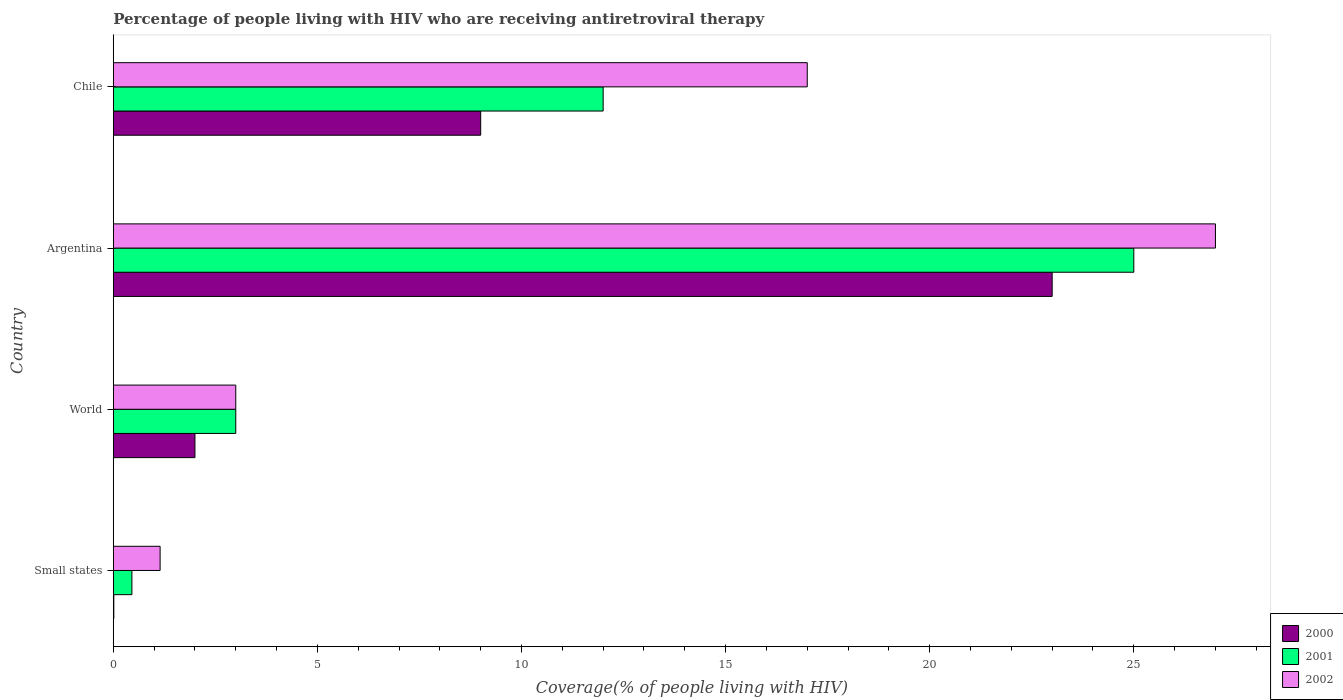How many groups of bars are there?
Offer a very short reply. 4. Are the number of bars per tick equal to the number of legend labels?
Make the answer very short. Yes. Are the number of bars on each tick of the Y-axis equal?
Make the answer very short. Yes. How many bars are there on the 1st tick from the bottom?
Offer a terse response. 3. What is the percentage of the HIV infected people who are receiving antiretroviral therapy in 2000 in Argentina?
Ensure brevity in your answer.  23. Across all countries, what is the minimum percentage of the HIV infected people who are receiving antiretroviral therapy in 2002?
Your answer should be compact. 1.15. In which country was the percentage of the HIV infected people who are receiving antiretroviral therapy in 2000 minimum?
Make the answer very short. Small states. What is the total percentage of the HIV infected people who are receiving antiretroviral therapy in 2001 in the graph?
Offer a terse response. 40.45. What is the difference between the percentage of the HIV infected people who are receiving antiretroviral therapy in 2002 in Small states and that in World?
Offer a very short reply. -1.85. What is the difference between the percentage of the HIV infected people who are receiving antiretroviral therapy in 2000 in Small states and the percentage of the HIV infected people who are receiving antiretroviral therapy in 2001 in Chile?
Your response must be concise. -11.99. What is the average percentage of the HIV infected people who are receiving antiretroviral therapy in 2002 per country?
Make the answer very short. 12.04. What is the difference between the percentage of the HIV infected people who are receiving antiretroviral therapy in 2000 and percentage of the HIV infected people who are receiving antiretroviral therapy in 2002 in Chile?
Give a very brief answer. -8. What is the ratio of the percentage of the HIV infected people who are receiving antiretroviral therapy in 2000 in Small states to that in World?
Make the answer very short. 0.01. Is the difference between the percentage of the HIV infected people who are receiving antiretroviral therapy in 2000 in Argentina and Small states greater than the difference between the percentage of the HIV infected people who are receiving antiretroviral therapy in 2002 in Argentina and Small states?
Your response must be concise. No. What is the difference between the highest and the lowest percentage of the HIV infected people who are receiving antiretroviral therapy in 2001?
Ensure brevity in your answer.  24.55. In how many countries, is the percentage of the HIV infected people who are receiving antiretroviral therapy in 2001 greater than the average percentage of the HIV infected people who are receiving antiretroviral therapy in 2001 taken over all countries?
Your response must be concise. 2. Is the sum of the percentage of the HIV infected people who are receiving antiretroviral therapy in 2001 in Chile and World greater than the maximum percentage of the HIV infected people who are receiving antiretroviral therapy in 2000 across all countries?
Make the answer very short. No. What does the 2nd bar from the top in Argentina represents?
Offer a terse response. 2001. What does the 3rd bar from the bottom in Argentina represents?
Give a very brief answer. 2002. How many bars are there?
Your response must be concise. 12. Are all the bars in the graph horizontal?
Your answer should be compact. Yes. How many countries are there in the graph?
Offer a terse response. 4. What is the difference between two consecutive major ticks on the X-axis?
Make the answer very short. 5. Are the values on the major ticks of X-axis written in scientific E-notation?
Your answer should be compact. No. Does the graph contain grids?
Your answer should be very brief. No. How many legend labels are there?
Make the answer very short. 3. How are the legend labels stacked?
Provide a short and direct response. Vertical. What is the title of the graph?
Make the answer very short. Percentage of people living with HIV who are receiving antiretroviral therapy. What is the label or title of the X-axis?
Your answer should be compact. Coverage(% of people living with HIV). What is the label or title of the Y-axis?
Give a very brief answer. Country. What is the Coverage(% of people living with HIV) of 2000 in Small states?
Make the answer very short. 0.01. What is the Coverage(% of people living with HIV) of 2001 in Small states?
Provide a short and direct response. 0.45. What is the Coverage(% of people living with HIV) of 2002 in Small states?
Your answer should be compact. 1.15. What is the Coverage(% of people living with HIV) in 2000 in World?
Ensure brevity in your answer.  2. What is the Coverage(% of people living with HIV) in 2001 in World?
Give a very brief answer. 3. What is the Coverage(% of people living with HIV) in 2002 in World?
Make the answer very short. 3. What is the Coverage(% of people living with HIV) of 2000 in Argentina?
Make the answer very short. 23. What is the Coverage(% of people living with HIV) in 2001 in Argentina?
Ensure brevity in your answer.  25. What is the Coverage(% of people living with HIV) of 2000 in Chile?
Ensure brevity in your answer.  9. What is the Coverage(% of people living with HIV) of 2001 in Chile?
Your answer should be compact. 12. Across all countries, what is the maximum Coverage(% of people living with HIV) in 2001?
Your answer should be compact. 25. Across all countries, what is the minimum Coverage(% of people living with HIV) in 2000?
Your response must be concise. 0.01. Across all countries, what is the minimum Coverage(% of people living with HIV) in 2001?
Your response must be concise. 0.45. Across all countries, what is the minimum Coverage(% of people living with HIV) in 2002?
Provide a succinct answer. 1.15. What is the total Coverage(% of people living with HIV) in 2000 in the graph?
Provide a short and direct response. 34.01. What is the total Coverage(% of people living with HIV) of 2001 in the graph?
Provide a succinct answer. 40.45. What is the total Coverage(% of people living with HIV) in 2002 in the graph?
Your answer should be compact. 48.15. What is the difference between the Coverage(% of people living with HIV) of 2000 in Small states and that in World?
Keep it short and to the point. -1.99. What is the difference between the Coverage(% of people living with HIV) in 2001 in Small states and that in World?
Provide a short and direct response. -2.54. What is the difference between the Coverage(% of people living with HIV) of 2002 in Small states and that in World?
Ensure brevity in your answer.  -1.85. What is the difference between the Coverage(% of people living with HIV) of 2000 in Small states and that in Argentina?
Offer a very short reply. -22.99. What is the difference between the Coverage(% of people living with HIV) in 2001 in Small states and that in Argentina?
Provide a short and direct response. -24.55. What is the difference between the Coverage(% of people living with HIV) in 2002 in Small states and that in Argentina?
Ensure brevity in your answer.  -25.85. What is the difference between the Coverage(% of people living with HIV) in 2000 in Small states and that in Chile?
Provide a short and direct response. -8.99. What is the difference between the Coverage(% of people living with HIV) of 2001 in Small states and that in Chile?
Offer a terse response. -11.54. What is the difference between the Coverage(% of people living with HIV) in 2002 in Small states and that in Chile?
Ensure brevity in your answer.  -15.85. What is the difference between the Coverage(% of people living with HIV) of 2000 in World and that in Argentina?
Keep it short and to the point. -21. What is the difference between the Coverage(% of people living with HIV) in 2000 in Small states and the Coverage(% of people living with HIV) in 2001 in World?
Provide a short and direct response. -2.99. What is the difference between the Coverage(% of people living with HIV) of 2000 in Small states and the Coverage(% of people living with HIV) of 2002 in World?
Your answer should be compact. -2.99. What is the difference between the Coverage(% of people living with HIV) of 2001 in Small states and the Coverage(% of people living with HIV) of 2002 in World?
Keep it short and to the point. -2.54. What is the difference between the Coverage(% of people living with HIV) of 2000 in Small states and the Coverage(% of people living with HIV) of 2001 in Argentina?
Provide a succinct answer. -24.99. What is the difference between the Coverage(% of people living with HIV) of 2000 in Small states and the Coverage(% of people living with HIV) of 2002 in Argentina?
Give a very brief answer. -26.99. What is the difference between the Coverage(% of people living with HIV) in 2001 in Small states and the Coverage(% of people living with HIV) in 2002 in Argentina?
Ensure brevity in your answer.  -26.55. What is the difference between the Coverage(% of people living with HIV) in 2000 in Small states and the Coverage(% of people living with HIV) in 2001 in Chile?
Offer a very short reply. -11.99. What is the difference between the Coverage(% of people living with HIV) of 2000 in Small states and the Coverage(% of people living with HIV) of 2002 in Chile?
Your answer should be compact. -16.99. What is the difference between the Coverage(% of people living with HIV) of 2001 in Small states and the Coverage(% of people living with HIV) of 2002 in Chile?
Keep it short and to the point. -16.55. What is the difference between the Coverage(% of people living with HIV) in 2000 in World and the Coverage(% of people living with HIV) in 2001 in Chile?
Offer a very short reply. -10. What is the difference between the Coverage(% of people living with HIV) of 2000 in World and the Coverage(% of people living with HIV) of 2002 in Chile?
Make the answer very short. -15. What is the difference between the Coverage(% of people living with HIV) in 2001 in Argentina and the Coverage(% of people living with HIV) in 2002 in Chile?
Offer a terse response. 8. What is the average Coverage(% of people living with HIV) in 2000 per country?
Keep it short and to the point. 8.5. What is the average Coverage(% of people living with HIV) in 2001 per country?
Offer a very short reply. 10.11. What is the average Coverage(% of people living with HIV) in 2002 per country?
Make the answer very short. 12.04. What is the difference between the Coverage(% of people living with HIV) in 2000 and Coverage(% of people living with HIV) in 2001 in Small states?
Your answer should be compact. -0.44. What is the difference between the Coverage(% of people living with HIV) of 2000 and Coverage(% of people living with HIV) of 2002 in Small states?
Offer a terse response. -1.13. What is the difference between the Coverage(% of people living with HIV) in 2001 and Coverage(% of people living with HIV) in 2002 in Small states?
Give a very brief answer. -0.69. What is the difference between the Coverage(% of people living with HIV) of 2000 and Coverage(% of people living with HIV) of 2001 in World?
Your answer should be very brief. -1. What is the difference between the Coverage(% of people living with HIV) of 2000 and Coverage(% of people living with HIV) of 2002 in World?
Your answer should be very brief. -1. What is the difference between the Coverage(% of people living with HIV) of 2000 and Coverage(% of people living with HIV) of 2001 in Argentina?
Your answer should be very brief. -2. What is the difference between the Coverage(% of people living with HIV) of 2000 and Coverage(% of people living with HIV) of 2002 in Argentina?
Ensure brevity in your answer.  -4. What is the difference between the Coverage(% of people living with HIV) in 2000 and Coverage(% of people living with HIV) in 2001 in Chile?
Keep it short and to the point. -3. What is the difference between the Coverage(% of people living with HIV) in 2001 and Coverage(% of people living with HIV) in 2002 in Chile?
Keep it short and to the point. -5. What is the ratio of the Coverage(% of people living with HIV) of 2000 in Small states to that in World?
Ensure brevity in your answer.  0.01. What is the ratio of the Coverage(% of people living with HIV) in 2001 in Small states to that in World?
Offer a very short reply. 0.15. What is the ratio of the Coverage(% of people living with HIV) of 2002 in Small states to that in World?
Provide a succinct answer. 0.38. What is the ratio of the Coverage(% of people living with HIV) of 2001 in Small states to that in Argentina?
Provide a short and direct response. 0.02. What is the ratio of the Coverage(% of people living with HIV) in 2002 in Small states to that in Argentina?
Your response must be concise. 0.04. What is the ratio of the Coverage(% of people living with HIV) in 2000 in Small states to that in Chile?
Your response must be concise. 0. What is the ratio of the Coverage(% of people living with HIV) in 2001 in Small states to that in Chile?
Your response must be concise. 0.04. What is the ratio of the Coverage(% of people living with HIV) in 2002 in Small states to that in Chile?
Your response must be concise. 0.07. What is the ratio of the Coverage(% of people living with HIV) in 2000 in World to that in Argentina?
Provide a short and direct response. 0.09. What is the ratio of the Coverage(% of people living with HIV) in 2001 in World to that in Argentina?
Offer a terse response. 0.12. What is the ratio of the Coverage(% of people living with HIV) of 2002 in World to that in Argentina?
Your answer should be compact. 0.11. What is the ratio of the Coverage(% of people living with HIV) in 2000 in World to that in Chile?
Your answer should be very brief. 0.22. What is the ratio of the Coverage(% of people living with HIV) in 2001 in World to that in Chile?
Offer a very short reply. 0.25. What is the ratio of the Coverage(% of people living with HIV) in 2002 in World to that in Chile?
Your answer should be very brief. 0.18. What is the ratio of the Coverage(% of people living with HIV) in 2000 in Argentina to that in Chile?
Keep it short and to the point. 2.56. What is the ratio of the Coverage(% of people living with HIV) in 2001 in Argentina to that in Chile?
Your response must be concise. 2.08. What is the ratio of the Coverage(% of people living with HIV) of 2002 in Argentina to that in Chile?
Offer a very short reply. 1.59. What is the difference between the highest and the second highest Coverage(% of people living with HIV) of 2000?
Ensure brevity in your answer.  14. What is the difference between the highest and the second highest Coverage(% of people living with HIV) of 2001?
Provide a short and direct response. 13. What is the difference between the highest and the lowest Coverage(% of people living with HIV) in 2000?
Offer a very short reply. 22.99. What is the difference between the highest and the lowest Coverage(% of people living with HIV) of 2001?
Offer a terse response. 24.55. What is the difference between the highest and the lowest Coverage(% of people living with HIV) of 2002?
Your answer should be very brief. 25.85. 